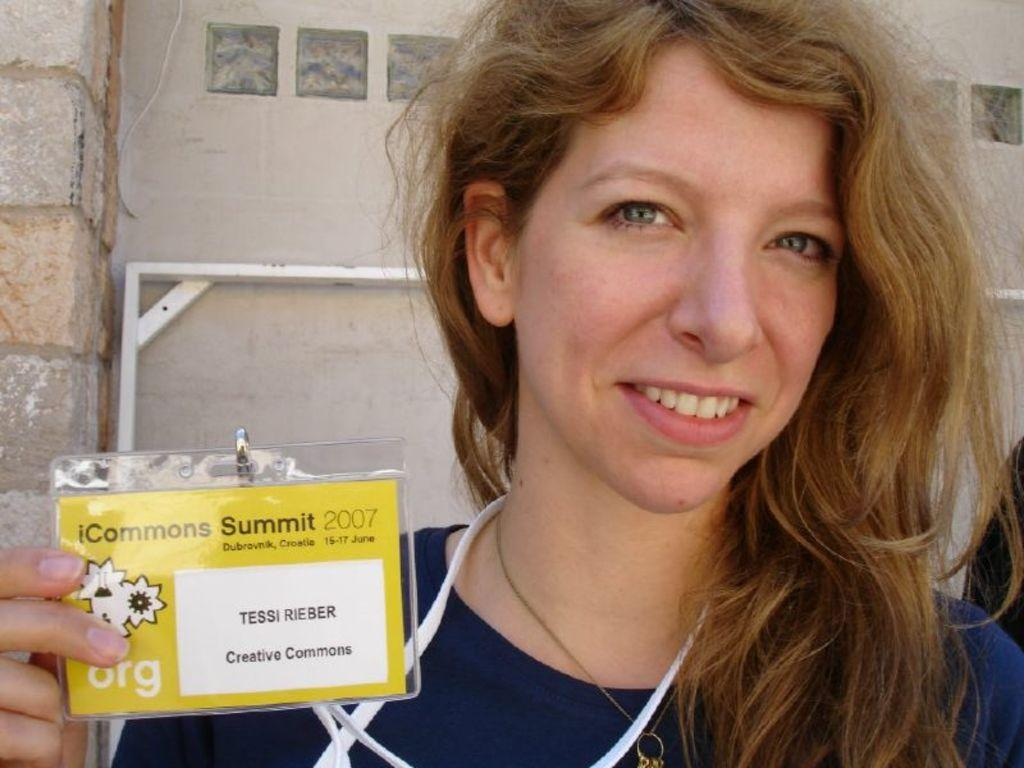Who is present in the image? There is a woman in the image. What is the woman holding in the image? The woman is holding an ID card. What can be seen in the background of the image? There is a wall in the background of the image. What type of development is taking place in the image? There is no development taking place in the image; it features a woman holding an ID card with a wall in the background. Can you see a chessboard in the image? There is no chessboard present in the image. 